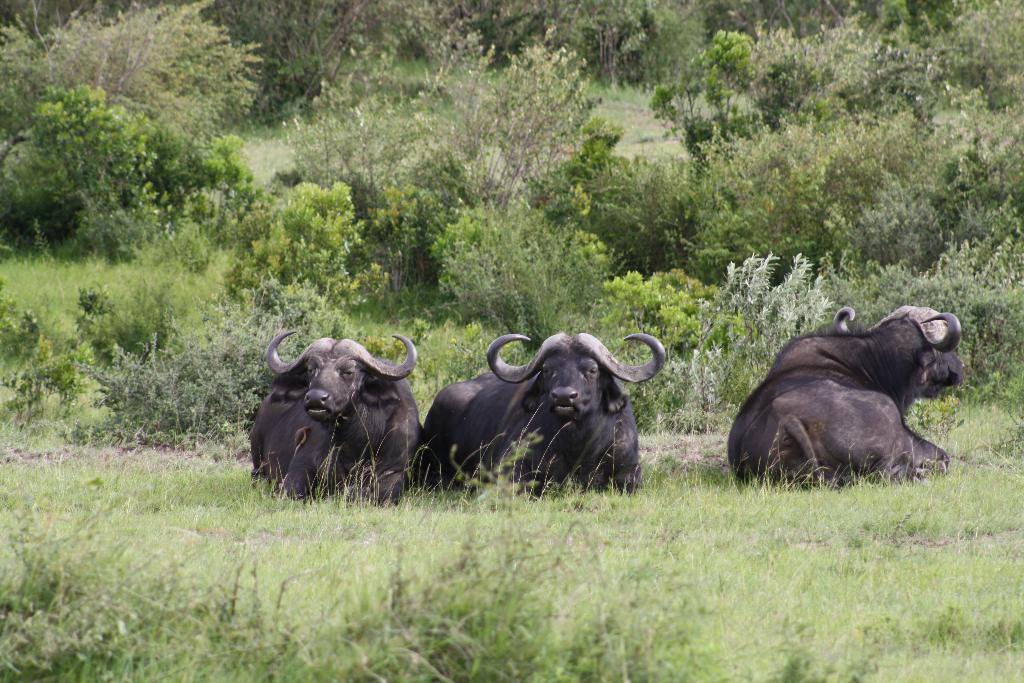How many buffaloes are present in the image? There are three buffaloes in the image. What type of vegetation can be seen in the image? There are trees and plants in the image. What is covering the ground in the image? There is grass on the ground in the image. What emotion does the goose in the image display? There is no goose present in the image, so it is not possible to determine any emotions displayed by a goose. 